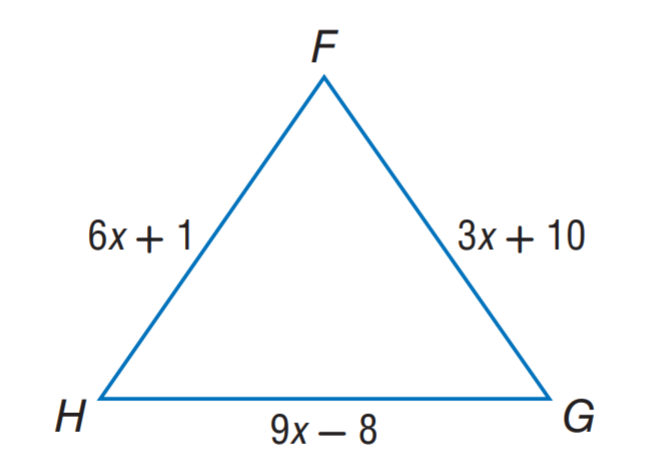Answer the mathemtical geometry problem and directly provide the correct option letter.
Question: \triangle F G H is an equilateral triangle. Find F G.
Choices: A: 3 B: 16 C: 19 D: 22 C 